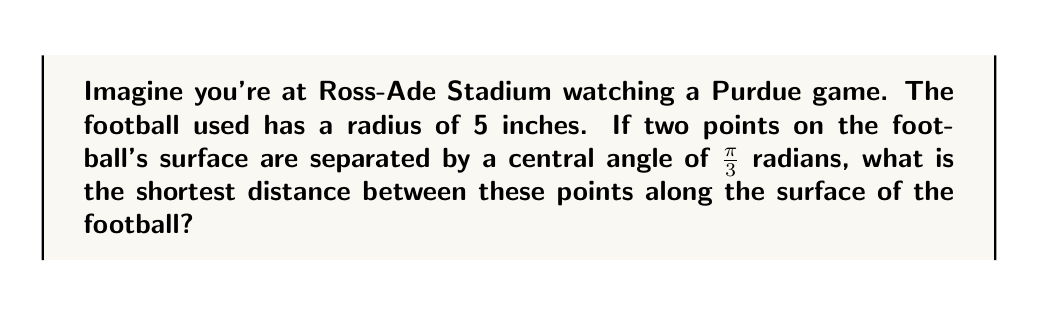Can you solve this math problem? Let's approach this step-by-step:

1) In spherical geometry, the shortest path between two points on a sphere is along a great circle. This path is called a geodesic.

2) The length of this path is proportional to the central angle between the two points.

3) The formula for the length of an arc on a sphere is:

   $$s = r\theta$$

   where $s$ is the arc length, $r$ is the radius of the sphere, and $\theta$ is the central angle in radians.

4) We are given:
   - Radius of the football, $r = 5$ inches
   - Central angle, $\theta = \frac{\pi}{3}$ radians

5) Plugging these values into our formula:

   $$s = 5 \cdot \frac{\pi}{3}$$

6) Simplifying:

   $$s = \frac{5\pi}{3} \approx 5.236$$

[asy]
import geometry;

size(200);
draw(Circle((0,0),5));
draw((0,0)--(5,0),dashed);
draw((0,0)--(2.5,4.33),dashed);
draw(arc((0,0),5,0,60),linewidth(1.5));
label("$\frac{\pi}{3}$",(1,0.5),NE);
label("5",(2.5,0),S);
label("$s$",(4,2),NE);
[/asy]

Therefore, the shortest distance between the two points on the surface of the football is approximately 5.236 inches.
Answer: $\frac{5\pi}{3}$ inches 